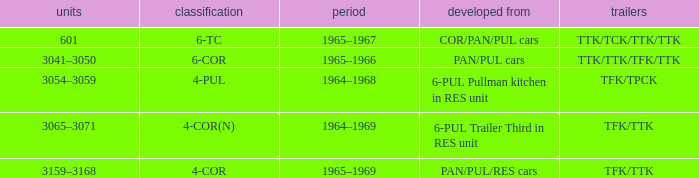Name the trailers for formed from pan/pul/res cars TFK/TTK. 